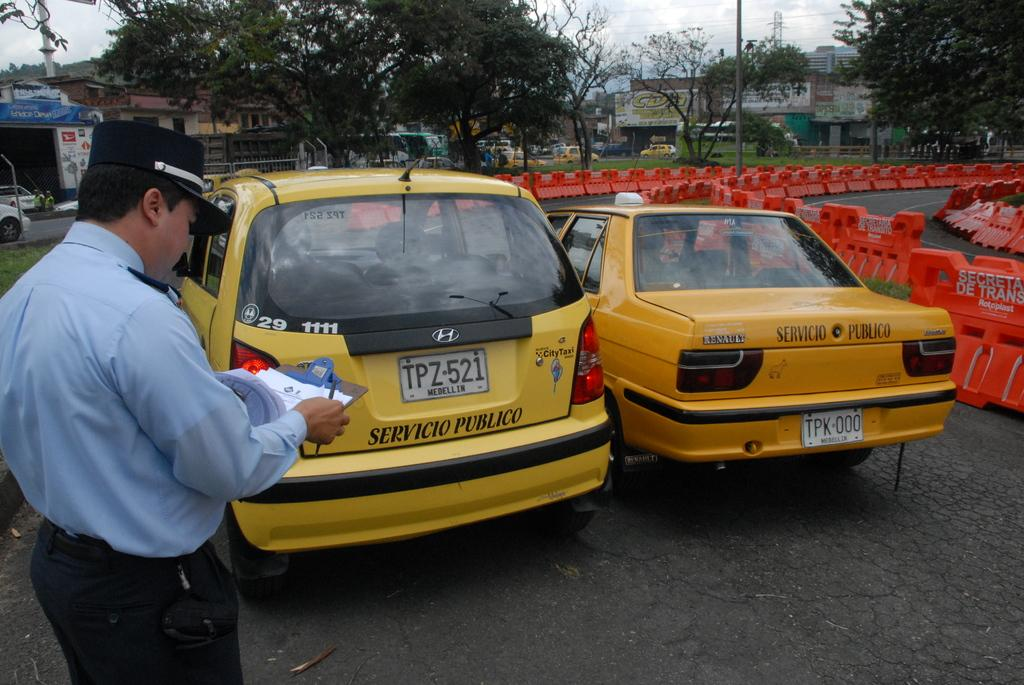<image>
Describe the image concisely. Two yellow vehicles with a man with a clipboard standing to the left 